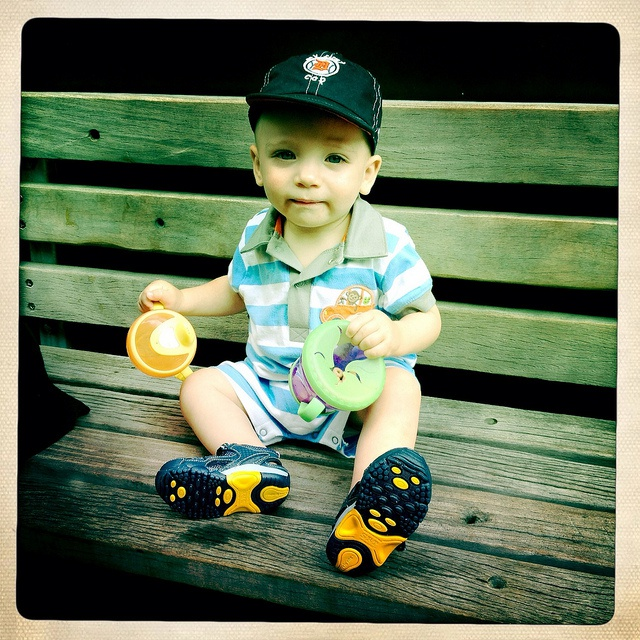Describe the objects in this image and their specific colors. I can see bench in beige, black, green, olive, and darkgreen tones, people in beige, black, khaki, and lightblue tones, cup in beige, lightgreen, lightyellow, and darkgray tones, and cup in beige, khaki, lightyellow, gold, and orange tones in this image. 